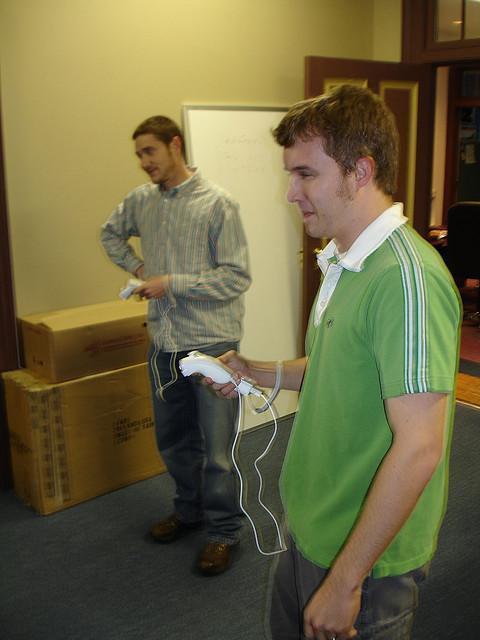How many people are in the picture?
Give a very brief answer. 2. 